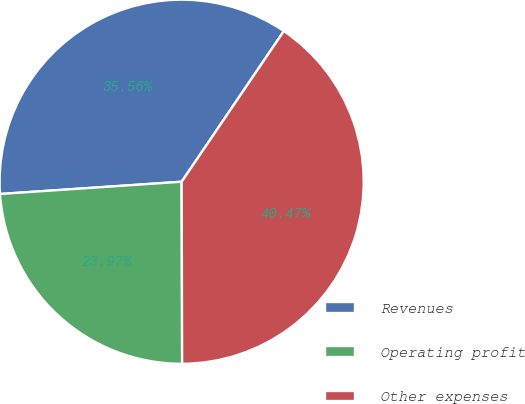Convert chart. <chart><loc_0><loc_0><loc_500><loc_500><pie_chart><fcel>Revenues<fcel>Operating profit<fcel>Other expenses<nl><fcel>35.56%<fcel>23.97%<fcel>40.47%<nl></chart> 